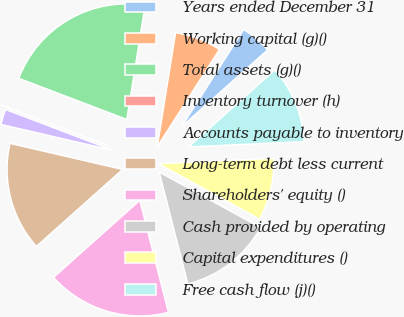Convert chart. <chart><loc_0><loc_0><loc_500><loc_500><pie_chart><fcel>Years ended December 31<fcel>Working capital (g)()<fcel>Total assets (g)()<fcel>Inventory turnover (h)<fcel>Accounts payable to inventory<fcel>Long-term debt less current<fcel>Shareholders' equity ()<fcel>Cash provided by operating<fcel>Capital expenditures ()<fcel>Free cash flow (j)()<nl><fcel>4.35%<fcel>6.52%<fcel>21.74%<fcel>0.0%<fcel>2.17%<fcel>15.22%<fcel>17.39%<fcel>13.04%<fcel>8.7%<fcel>10.87%<nl></chart> 